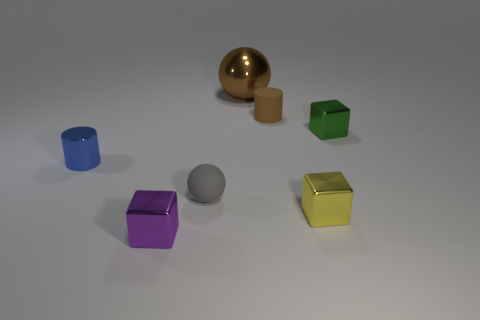There is a rubber object that is the same color as the large metallic thing; what is its shape?
Offer a very short reply. Cylinder. What number of brown cylinders have the same size as the blue metallic object?
Your response must be concise. 1. Does the cylinder left of the purple thing have the same material as the big brown thing?
Give a very brief answer. Yes. Is there a brown cylinder?
Offer a very short reply. Yes. What size is the purple object that is the same material as the large ball?
Provide a succinct answer. Small. Are there any other big shiny spheres of the same color as the metal ball?
Your answer should be very brief. No. Do the tiny cylinder left of the purple thing and the rubber object in front of the blue metallic cylinder have the same color?
Your response must be concise. No. What is the size of the matte cylinder that is the same color as the large object?
Ensure brevity in your answer.  Small. Are there any blue objects made of the same material as the large brown object?
Offer a very short reply. Yes. The large ball is what color?
Your response must be concise. Brown. 